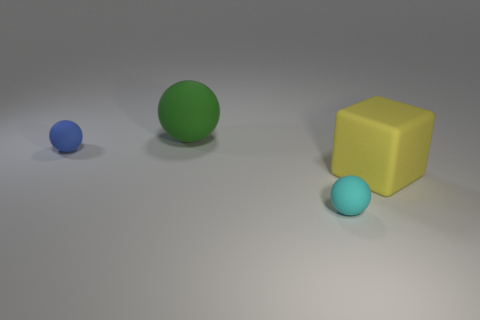Add 1 rubber balls. How many objects exist? 5 Subtract all spheres. How many objects are left? 1 Add 2 cyan rubber things. How many cyan rubber things are left? 3 Add 2 tiny matte objects. How many tiny matte objects exist? 4 Subtract 0 cyan cylinders. How many objects are left? 4 Subtract all tiny red cylinders. Subtract all green matte objects. How many objects are left? 3 